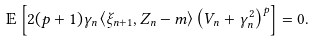Convert formula to latex. <formula><loc_0><loc_0><loc_500><loc_500>\mathbb { E } \left [ 2 ( p + 1 ) \gamma _ { n } \left \langle \xi _ { n + 1 } , Z _ { n } - m \right \rangle \left ( V _ { n } + \gamma _ { n } ^ { 2 } \right ) ^ { p } \right ] = 0 .</formula> 